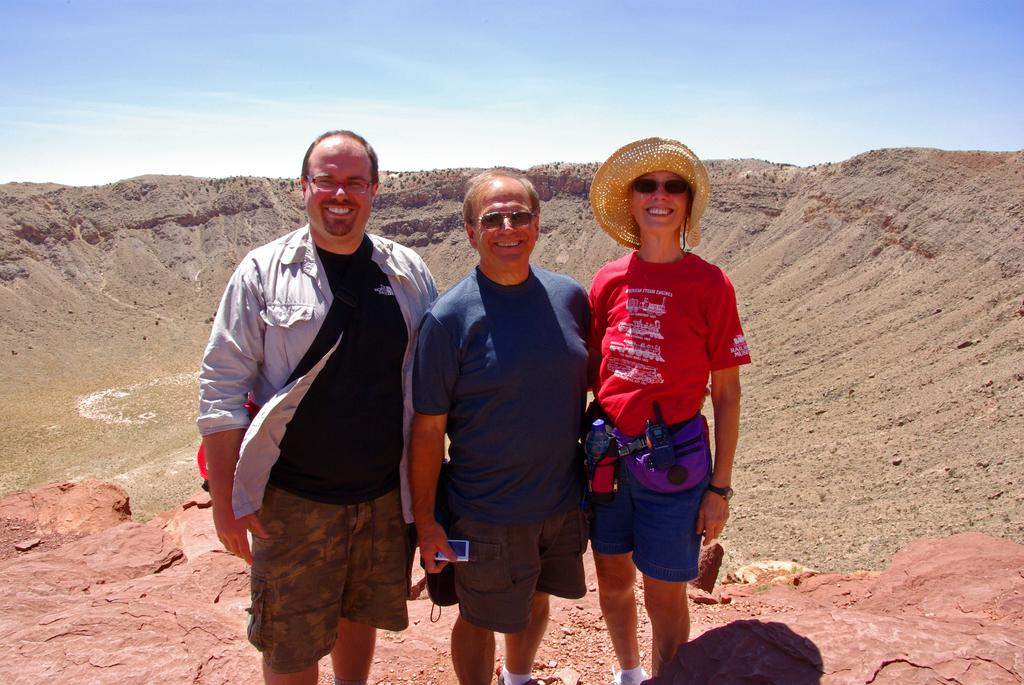How many people are in the image? There are three persons in the image. What are the persons doing in the image? The persons are standing on a rock and smiling. What type of surface can be seen in the background of the image? There is sand in the background of the image. What is visible in the sky in the image? The sky is visible in the background of the image. What type of net is being used by the fireman in the image? There is no fireman or net present in the image. Can you tell me how many pigs are visible in the image? There are no pigs present in the image. 